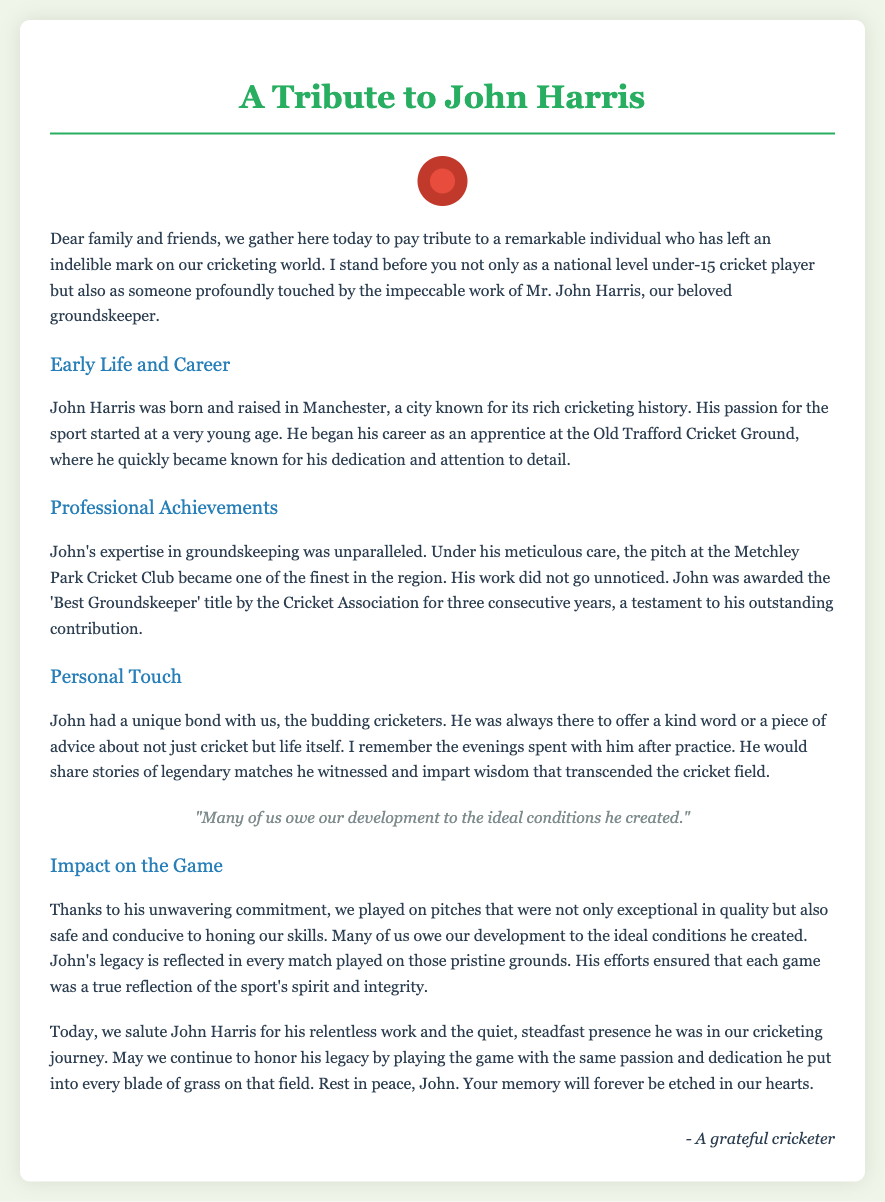What was John Harris's profession? The document states that John Harris was a groundskeeper, highlighting his importance in the cricketing world.
Answer: groundskeeper Where was John Harris born? The eulogy mentions that he was born and raised in Manchester, a city known for its rich cricketing history.
Answer: Manchester How many years was John awarded the 'Best Groundskeeper' title? It is stated in the document that he received the title for three consecutive years, indicating the duration of his recognition.
Answer: three What type of bond did John have with the budding cricketers? The eulogy describes his unique bond with the young players as one filled with kindness and supportive advice.
Answer: unique bond What impact did John have on the quality of the pitches? The document emphasizes his unwavering commitment, resulting in exceptional and safe pitches for cricketers to develop their skills.
Answer: exceptional quality What legacy did John leave behind in the cricketing community? The eulogy expresses that John’s legacy is reflected in each match played on the grounds he maintained, indicating his lasting impact.
Answer: legacy in every match Who wrote the tribute? The closing section indicates that a grateful cricketer wrote this heartfelt tribute to John Harris.
Answer: A grateful cricketer 